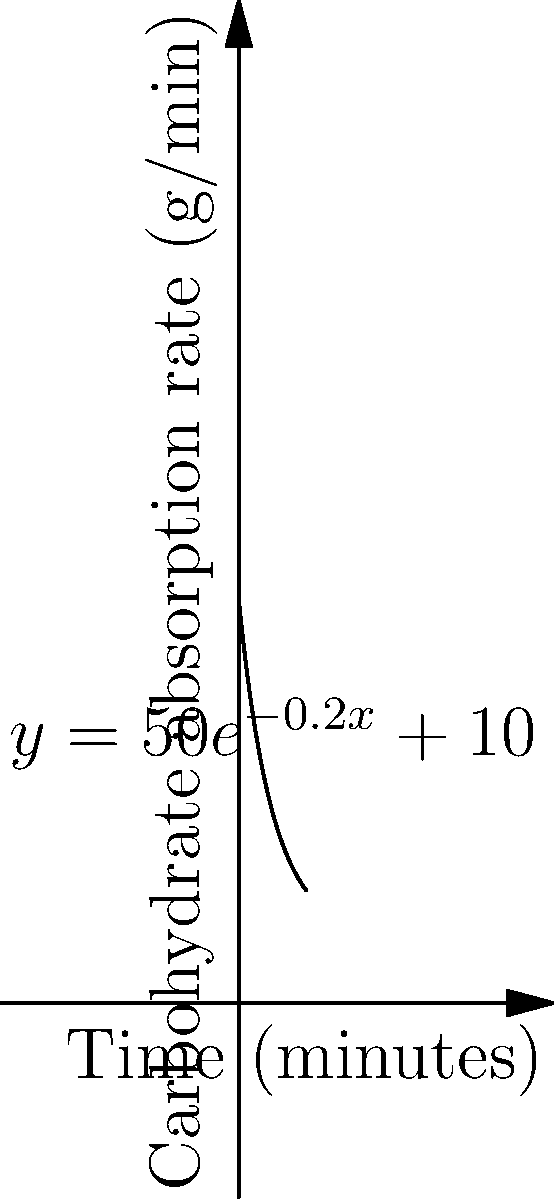The rate of carbohydrate absorption during intense exercise can be modeled by the function $y = 50e^{-0.2x} + 10$, where $y$ is the absorption rate in grams per minute and $x$ is the time in minutes since the start of exercise. At what rate is the carbohydrate absorption changing after 5 minutes of intense exercise? To find the rate of change of carbohydrate absorption at 5 minutes, we need to calculate the derivative of the given function and evaluate it at $x = 5$.

1) The given function is $y = 50e^{-0.2x} + 10$

2) To find the derivative, we use the chain rule:
   $\frac{dy}{dx} = 50 \cdot (-0.2) \cdot e^{-0.2x} + 0 = -10e^{-0.2x}$

3) Now we evaluate this derivative at $x = 5$:
   $\frac{dy}{dx}\Big|_{x=5} = -10e^{-0.2(5)} = -10e^{-1} \approx -3.68$

4) The negative value indicates that the absorption rate is decreasing.

Therefore, after 5 minutes of intense exercise, the carbohydrate absorption rate is decreasing at approximately 3.68 grams per minute per minute.
Answer: $-3.68$ g/min² 